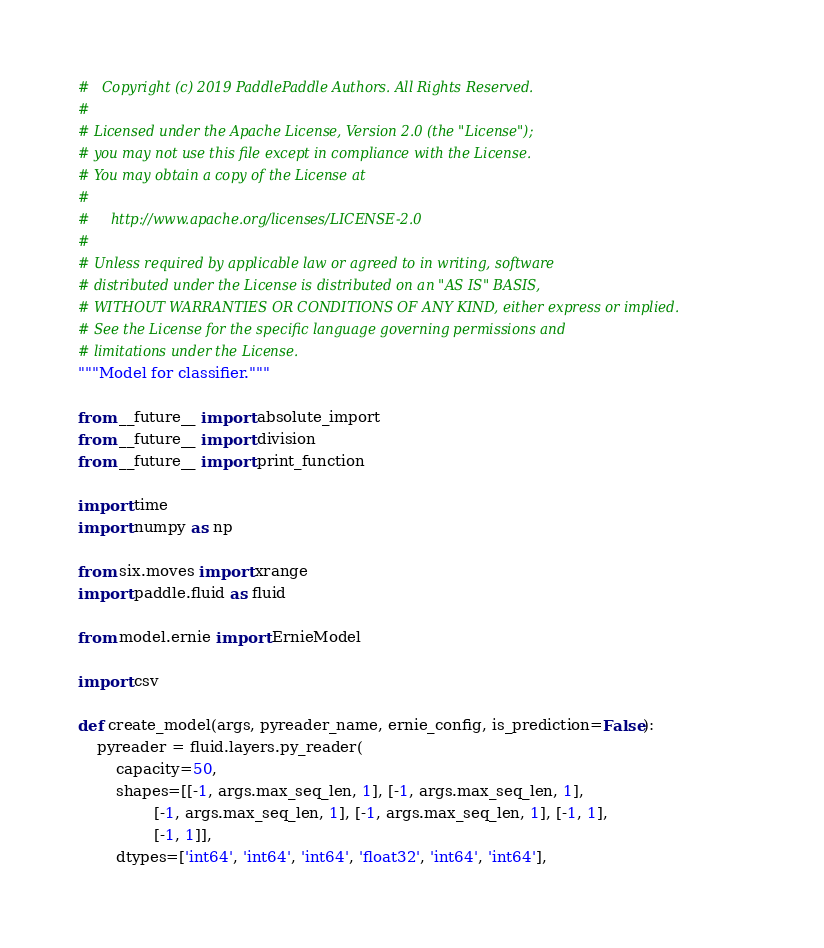<code> <loc_0><loc_0><loc_500><loc_500><_Python_>#   Copyright (c) 2019 PaddlePaddle Authors. All Rights Reserved.
#
# Licensed under the Apache License, Version 2.0 (the "License");
# you may not use this file except in compliance with the License.
# You may obtain a copy of the License at
#
#     http://www.apache.org/licenses/LICENSE-2.0
#
# Unless required by applicable law or agreed to in writing, software
# distributed under the License is distributed on an "AS IS" BASIS,
# WITHOUT WARRANTIES OR CONDITIONS OF ANY KIND, either express or implied.
# See the License for the specific language governing permissions and
# limitations under the License.
"""Model for classifier."""

from __future__ import absolute_import
from __future__ import division
from __future__ import print_function

import time
import numpy as np

from six.moves import xrange
import paddle.fluid as fluid

from model.ernie import ErnieModel

import csv

def create_model(args, pyreader_name, ernie_config, is_prediction=False):
    pyreader = fluid.layers.py_reader(
        capacity=50,
        shapes=[[-1, args.max_seq_len, 1], [-1, args.max_seq_len, 1],
                [-1, args.max_seq_len, 1], [-1, args.max_seq_len, 1], [-1, 1],
                [-1, 1]],
        dtypes=['int64', 'int64', 'int64', 'float32', 'int64', 'int64'],</code> 